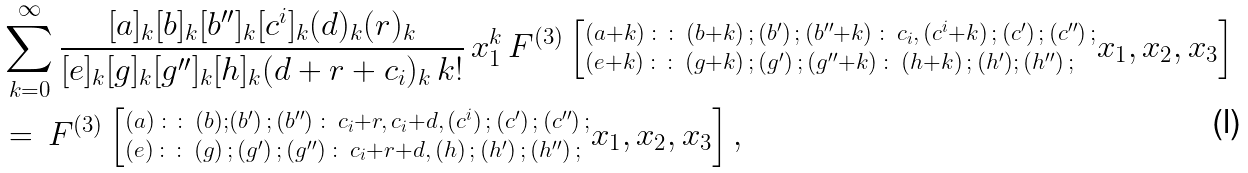<formula> <loc_0><loc_0><loc_500><loc_500>\ & \sum _ { k = 0 } ^ { \infty } \frac { [ a ] _ { k } [ b ] _ { k } [ b ^ { \prime \prime } ] _ { k } [ c ^ { i } ] _ { k } ( d ) _ { k } ( r ) _ { k } } { [ e ] _ { k } [ g ] _ { k } [ g ^ { \prime \prime } ] _ { k } [ h ] _ { k } ( d + r + c _ { i } ) _ { k } \, k ! } \, x _ { 1 } ^ { k } \, F ^ { ( 3 ) } \left [ ^ { ( a + k ) \, \colon \colon \, ( b + k ) \, ; \, ( b ^ { \prime } ) \, ; \, ( b ^ { \prime \prime } + k ) \, \colon \, c _ { i } , \, ( c ^ { i } + k ) \, ; \, ( c ^ { \prime } ) \, ; \, ( c ^ { \prime \prime } ) \, ; } _ { ( e + k ) \, \colon \colon \, ( g + k ) \, ; \, ( g ^ { \prime } ) \, ; \, ( g ^ { \prime \prime } + k ) \, \colon \, ( h + k ) \, ; \, ( h ^ { \prime } ) ; \, ( h ^ { \prime \prime } ) \, ; } x _ { 1 } , x _ { 2 } , x _ { 3 } \right ] \\ & = \, F ^ { ( 3 ) } \left [ ^ { ( a ) \, \colon \colon \, ( b ) ; ( b ^ { \prime } ) \, ; \, ( b ^ { \prime \prime } ) \, \colon \, c _ { i } + r , \, c _ { i } + d , \, ( c ^ { i } ) \, ; \, ( c ^ { \prime } ) \, ; \, ( c ^ { \prime \prime } ) \, ; } _ { ( e ) \, \colon \colon \, ( g ) \, ; \, ( g ^ { \prime } ) \, ; \, ( g ^ { \prime \prime } ) \, \colon \, c _ { i } + r + d , \, ( h ) \, ; \, ( h ^ { \prime } ) \, ; \, ( h ^ { \prime \prime } ) \, ; } x _ { 1 } , x _ { 2 } , x _ { 3 } \right ] ,</formula> 